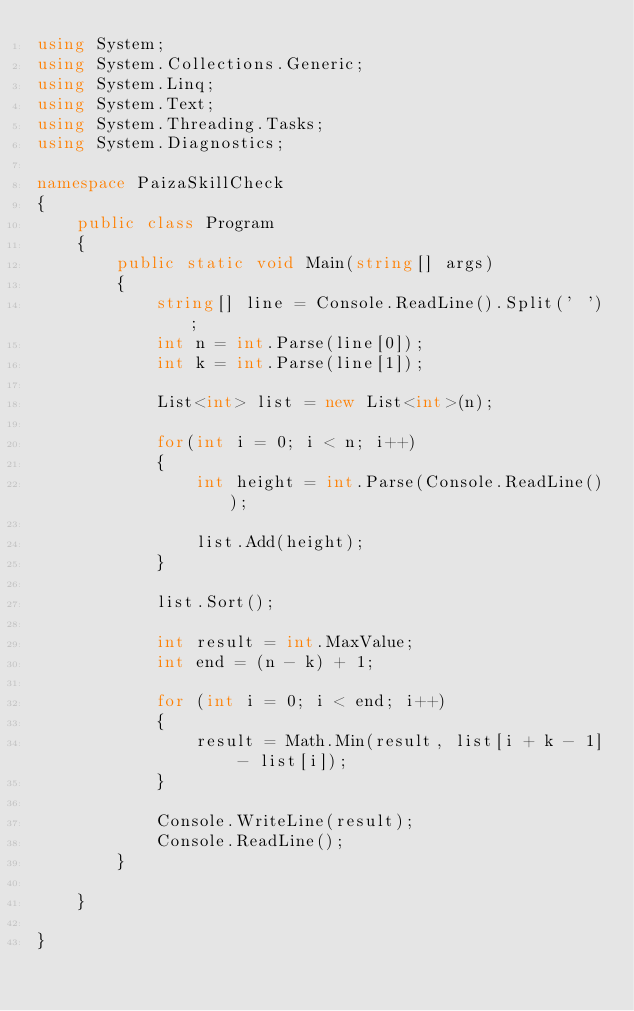<code> <loc_0><loc_0><loc_500><loc_500><_C#_>using System;
using System.Collections.Generic;
using System.Linq;
using System.Text;
using System.Threading.Tasks;
using System.Diagnostics;

namespace PaizaSkillCheck
{
    public class Program
    {
        public static void Main(string[] args)
        {
            string[] line = Console.ReadLine().Split(' ');
            int n = int.Parse(line[0]);
            int k = int.Parse(line[1]);

            List<int> list = new List<int>(n);

            for(int i = 0; i < n; i++)
            {
                int height = int.Parse(Console.ReadLine());

                list.Add(height);
            }

            list.Sort();

            int result = int.MaxValue;
            int end = (n - k) + 1;

            for (int i = 0; i < end; i++)
            {
                result = Math.Min(result, list[i + k - 1] - list[i]);
            }

            Console.WriteLine(result);
            Console.ReadLine();
        }

    }

}
</code> 